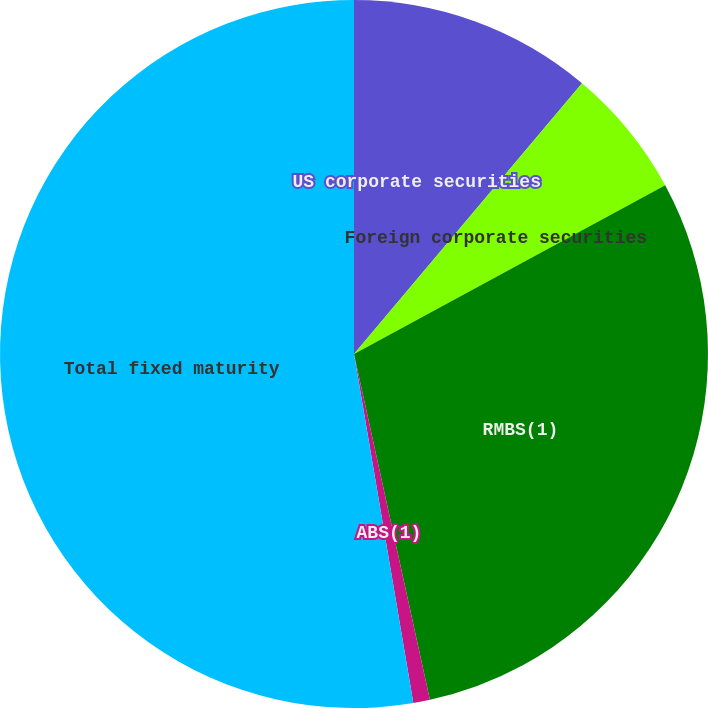Convert chart. <chart><loc_0><loc_0><loc_500><loc_500><pie_chart><fcel>US corporate securities<fcel>Foreign corporate securities<fcel>RMBS(1)<fcel>ABS(1)<fcel>Total fixed maturity<nl><fcel>11.14%<fcel>5.95%<fcel>29.47%<fcel>0.76%<fcel>52.68%<nl></chart> 